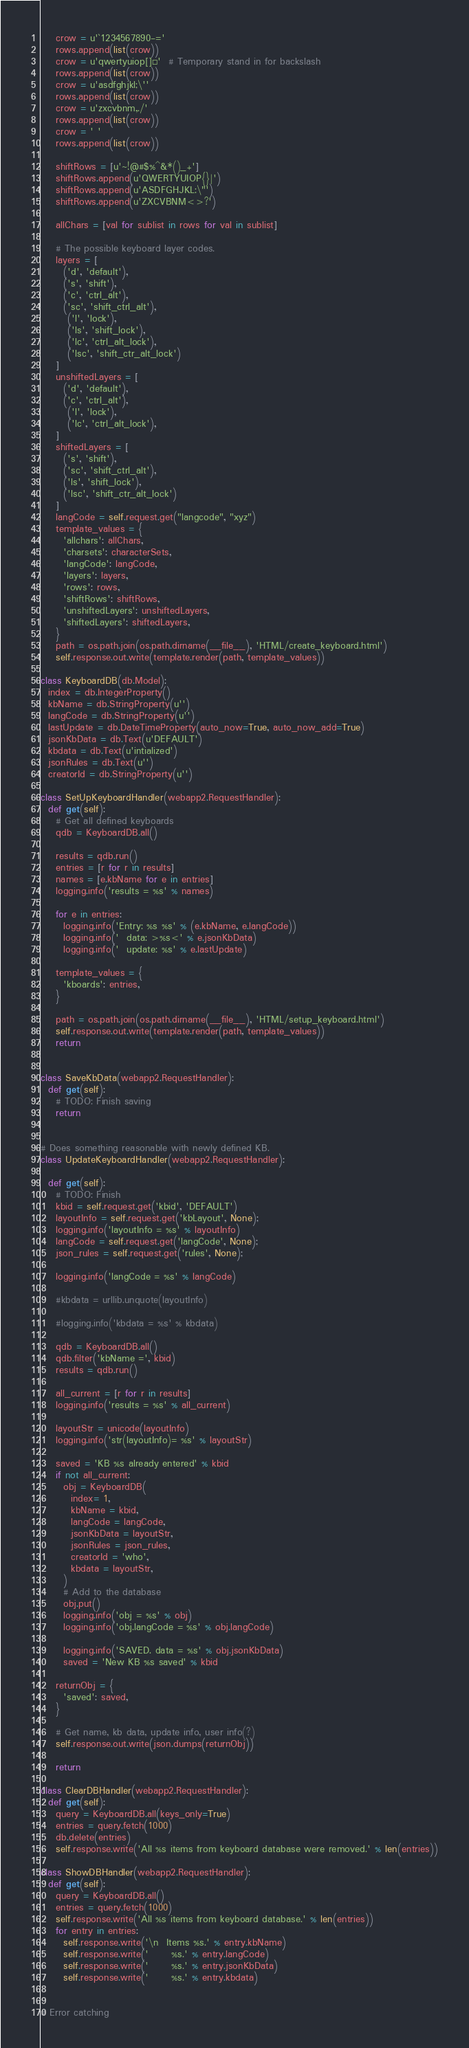Convert code to text. <code><loc_0><loc_0><loc_500><loc_500><_Python_>    crow = u'`1234567890-='
    rows.append(list(crow))
    crow = u'qwertyuiop[]¡'  # Temporary stand in for backslash
    rows.append(list(crow))
    crow = u'asdfghjkl;\''
    rows.append(list(crow))
    crow = u'zxcvbnm,./'
    rows.append(list(crow))
    crow = ' '
    rows.append(list(crow))

    shiftRows = [u'~!@#$%^&*()_+']
    shiftRows.append(u'QWERTYUIOP{}|')
    shiftRows.append(u'ASDFGHJKL:\"')
    shiftRows.append(u'ZXCVBNM<>?')

    allChars = [val for sublist in rows for val in sublist]

    # The possible keyboard layer codes.
    layers = [
      ('d', 'default'),
      ('s', 'shift'),
      ('c', 'ctrl_alt'),
      ('sc', 'shift_ctrl_alt'),
       ('l', 'lock'),
       ('ls', 'shift_lock'),
       ('lc', 'ctrl_alt_lock'),
       ('lsc', 'shift_ctr_alt_lock')
    ]
    unshiftedLayers = [
      ('d', 'default'),
      ('c', 'ctrl_alt'),
       ('l', 'lock'),
       ('lc', 'ctrl_alt_lock'),
    ]
    shiftedLayers = [
      ('s', 'shift'),
      ('sc', 'shift_ctrl_alt'),
      ('ls', 'shift_lock'),
      ('lsc', 'shift_ctr_alt_lock')
    ]
    langCode = self.request.get("langcode", "xyz")
    template_values = {
      'allchars': allChars,
      'charsets': characterSets,
      'langCode': langCode,
      'layers': layers,
      'rows': rows,
      'shiftRows': shiftRows,
      'unshiftedLayers': unshiftedLayers,
      'shiftedLayers': shiftedLayers,
    }
    path = os.path.join(os.path.dirname(__file__), 'HTML/create_keyboard.html')
    self.response.out.write(template.render(path, template_values))

class KeyboardDB(db.Model):
  index = db.IntegerProperty()
  kbName = db.StringProperty(u'')
  langCode = db.StringProperty(u'')
  lastUpdate = db.DateTimeProperty(auto_now=True, auto_now_add=True)
  jsonKbData = db.Text(u'DEFAULT')
  kbdata = db.Text(u'intialized')
  jsonRules = db.Text(u'')
  creatorId = db.StringProperty(u'')

class SetUpKeyboardHandler(webapp2.RequestHandler):
  def get(self):
    # Get all defined keyboards
    qdb = KeyboardDB.all()

    results = qdb.run()
    entries = [r for r in results]
    names = [e.kbName for e in entries]
    logging.info('results = %s' % names)

    for e in entries:
      logging.info('Entry: %s %s' % (e.kbName, e.langCode))
      logging.info('  data: >%s<' % e.jsonKbData)
      logging.info('  update: %s' % e.lastUpdate)

    template_values = {
      'kboards': entries,
    }

    path = os.path.join(os.path.dirname(__file__), 'HTML/setup_keyboard.html')
    self.response.out.write(template.render(path, template_values))
    return


class SaveKbData(webapp2.RequestHandler):
  def get(self):
    # TODO: Finish saving
    return


# Does something reasonable with newly defined KB.
class UpdateKeyboardHandler(webapp2.RequestHandler):

  def get(self):
    # TODO: Finish
    kbid = self.request.get('kbid', 'DEFAULT')
    layoutInfo = self.request.get('kbLayout', None);
    logging.info('layoutInfo = %s' % layoutInfo)
    langCode = self.request.get('langCode', None);
    json_rules = self.request.get('rules', None);

    logging.info('langCode = %s' % langCode)

    #kbdata = urllib.unquote(layoutInfo)

    #logging.info('kbdata = %s' % kbdata)

    qdb = KeyboardDB.all()
    qdb.filter('kbName =', kbid)
    results = qdb.run()

    all_current = [r for r in results]
    logging.info('results = %s' % all_current)

    layoutStr = unicode(layoutInfo)
    logging.info('str(layoutInfo)= %s' % layoutStr)

    saved = 'KB %s already entered' % kbid
    if not all_current:
      obj = KeyboardDB(
        index= 1,
        kbName = kbid,
        langCode = langCode,
        jsonKbData = layoutStr,
        jsonRules = json_rules,
        creatorId = 'who',
        kbdata = layoutStr,
      )
      # Add to the database
      obj.put()
      logging.info('obj = %s' % obj)
      logging.info('obj.langCode = %s' % obj.langCode)

      logging.info('SAVED. data = %s' % obj.jsonKbData)
      saved = 'New KB %s saved' % kbid

    returnObj = {
      'saved': saved,
    }

    # Get name, kb data, update info, user info(?)
    self.response.out.write(json.dumps(returnObj))

    return

class ClearDBHandler(webapp2.RequestHandler):
  def get(self):
    query = KeyboardDB.all(keys_only=True)
    entries = query.fetch(1000)
    db.delete(entries)
    self.response.write('All %s items from keyboard database were removed.' % len(entries))

class ShowDBHandler(webapp2.RequestHandler):
  def get(self):
    query = KeyboardDB.all()
    entries = query.fetch(1000)
    self.response.write('All %s items from keyboard database.' % len(entries))
    for entry in entries:
      self.response.write('\n  Items %s.' % entry.kbName)
      self.response.write('      %s.' % entry.langCode)
      self.response.write('      %s.' % entry.jsonKbData)
      self.response.write('      %s.' % entry.kbdata)


# Error catching</code> 